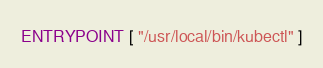Convert code to text. <code><loc_0><loc_0><loc_500><loc_500><_Dockerfile_>

ENTRYPOINT [ "/usr/local/bin/kubectl" ]</code> 